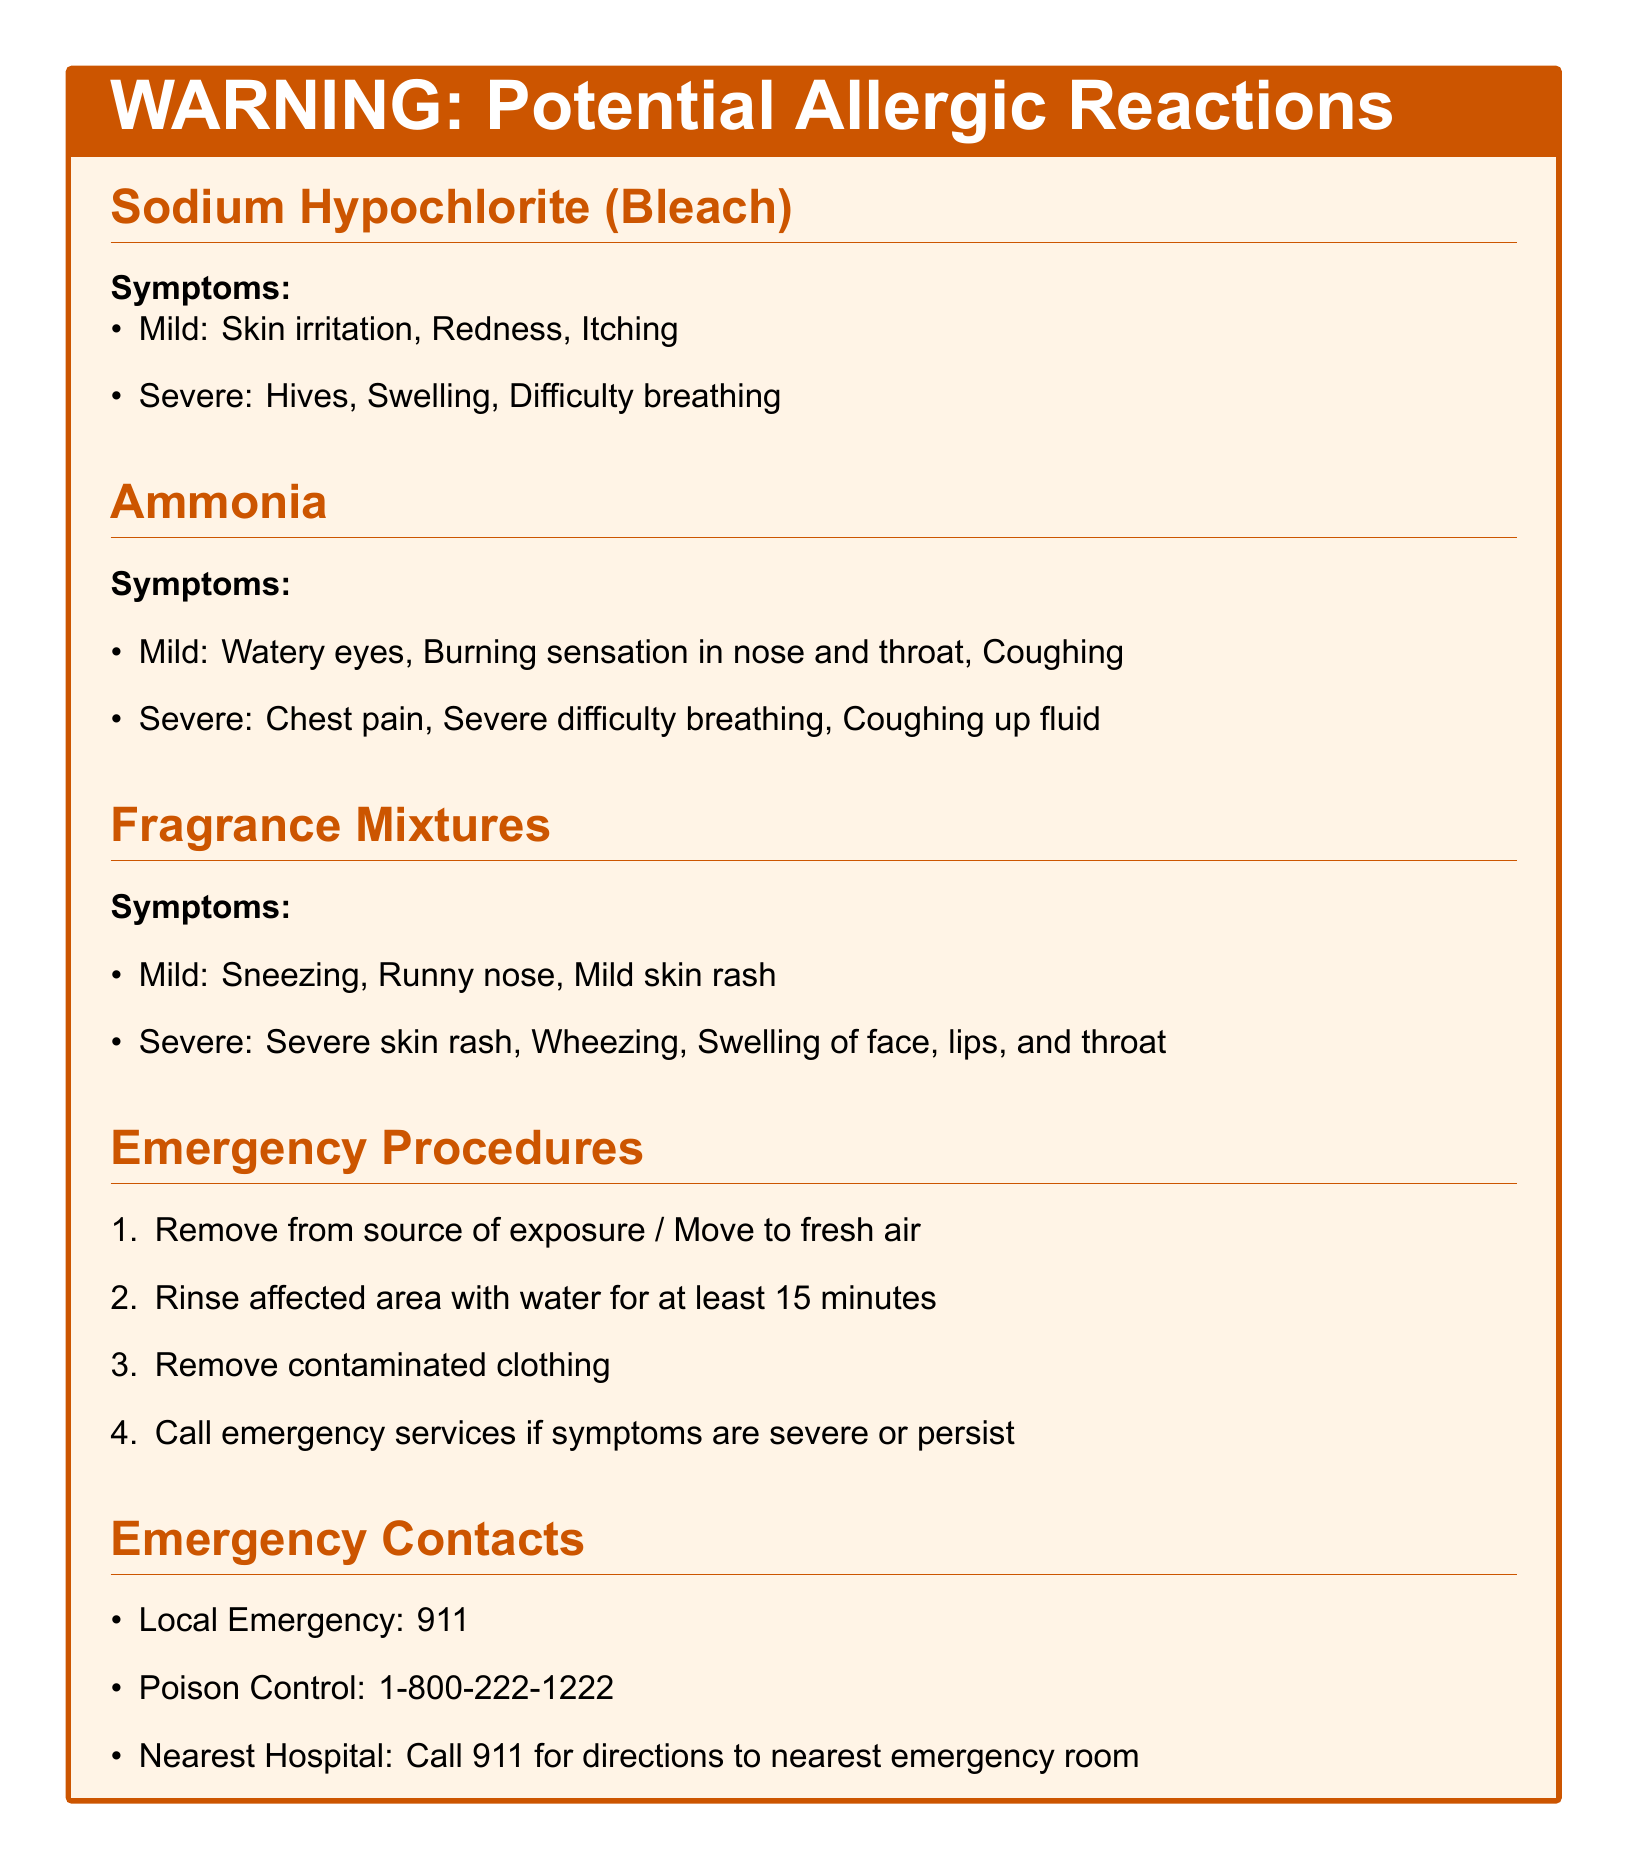What is the first symptom of Sodium Hypochlorite exposure? The first symptom listed under Sodium Hypochlorite is mild skin irritation.
Answer: Mild skin irritation What is the emergency contact number for Poison Control? The document lists the Poison Control number explicitly.
Answer: 1-800-222-1222 What are the severe symptoms of Ammonia exposure? The severe symptoms are outlined in the Ammonia section of the document.
Answer: Chest pain, Severe difficulty breathing, Coughing up fluid How long should you rinse affected areas with water in case of exposure? This information is specified under the emergency procedures section.
Answer: At least 15 minutes What is the immediate action to take after exposure to the cleaning product? The document specifies the first action to be taken in emergency procedures.
Answer: Remove from source of exposure / Move to fresh air Which section lists symptoms related to Fragrance Mixtures? The symptoms for Fragrance Mixtures are under the section specifically titled "Fragrance Mixtures."
Answer: Fragrance Mixtures What should you do if symptoms persist? This is outlined in the emergency procedures section of the document.
Answer: Call emergency services if symptoms are severe or persist What is the least severe symptom of Fragrance Mixture exposure? The least severe symptom is listed in the document.
Answer: Sneezing 